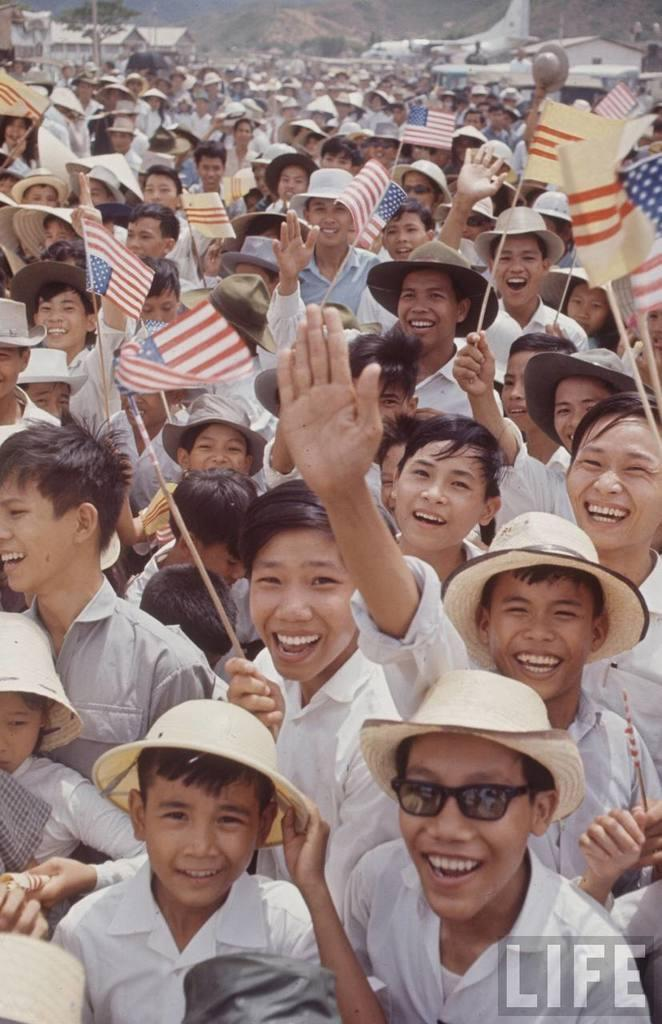What are the people in the image doing? The people in the image are holding flags. What can be seen in the distance in the image? There is a plane visible in the distance. What type of structures are present in the image? There are houses in the image. What type of vegetation is present in the image? There is a tree in the image. What is present on the right side of the image? There is a watermark on the right side of the image. What type of instrument is being played by the people in the image? There is no instrument being played by the people in the image; they are holding flags. What type of bushes can be seen in the image? There are no bushes present in the image. 